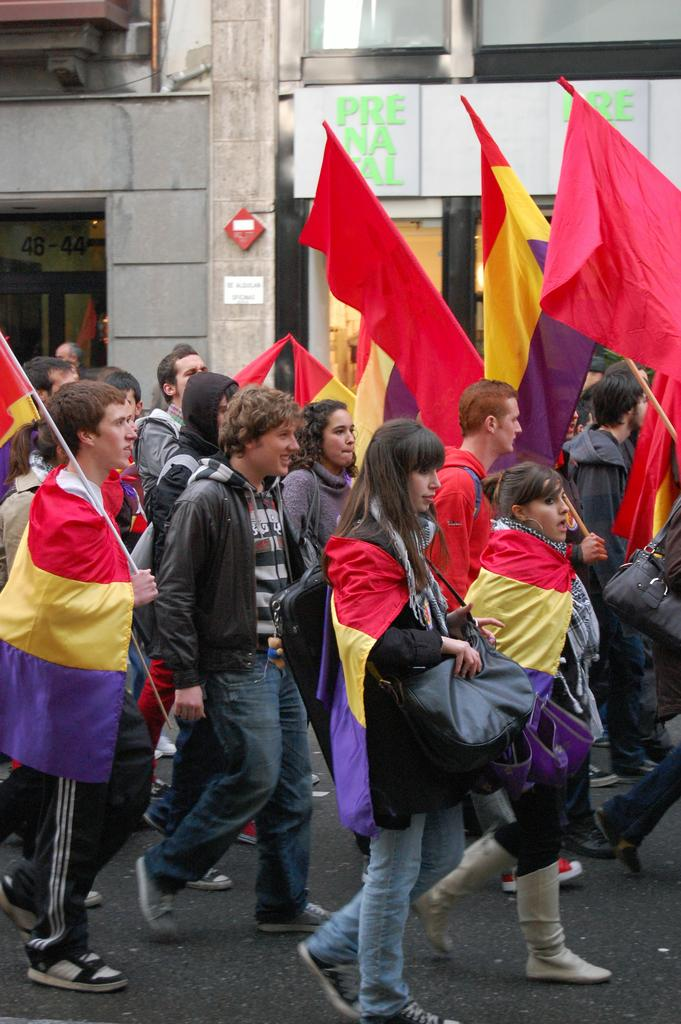What are the people in the image doing? The people in the image are walking on the road. What are some of the people holding? Some of the people are holding flags and some are holding bags. What is the emotional state of some of the people? Some of the people are smiling. What can be seen in the background of the image? There is a building in the background. What type of winter clothing can be seen on the people in the image? There is no mention of winter clothing in the image, as the facts provided do not indicate any specific season or weather conditions. 